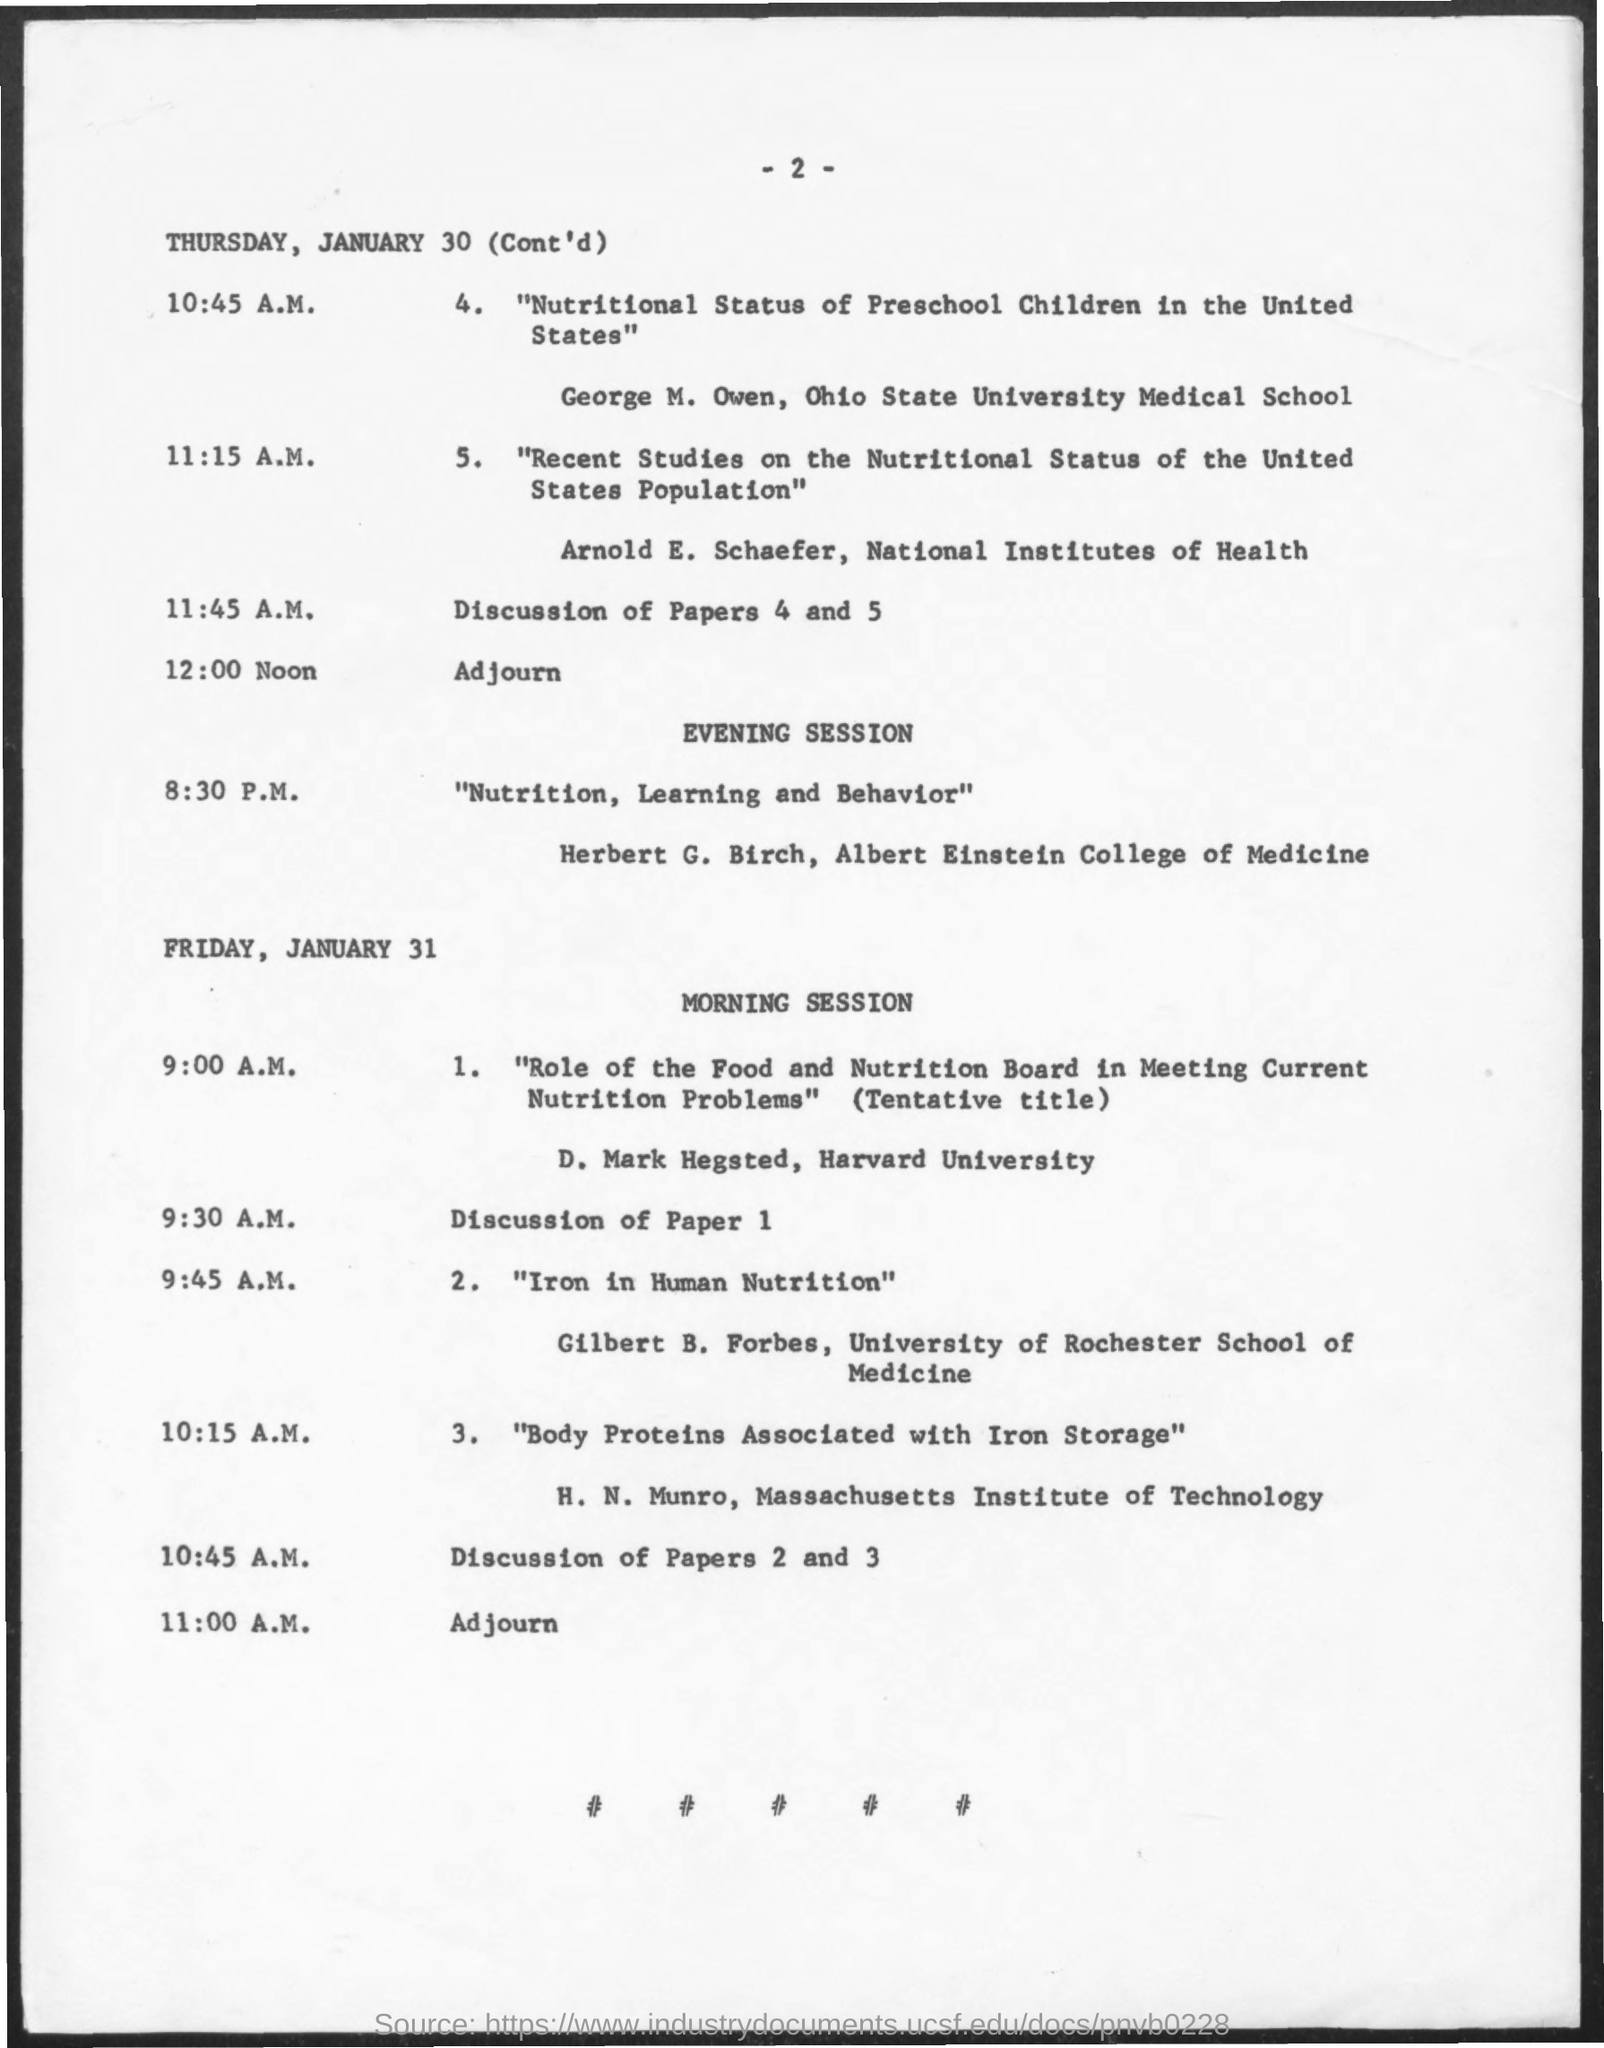Who conducted the paper on the topic " Nutritional Status of Preschool Children in the United states" on thursday?
Your answer should be compact. George M. Owen. When is the adjourn time on thursday?
Provide a short and direct response. 12:00 Noon. Who conducted the paper on the topic "Recent Studies on the Nutritional Status of the United States population" on thursday ?
Your answer should be compact. Arnold E. Schaefer. Who conducted the Paper on the topic "Role of the Food and Nutrition Board in Meeting Current Nutrition Problems" on Friday?
Keep it short and to the point. D. Mark Hegsted. Who conducted the paper on the topic " Iron in Human Nutrition " on Friday ?
Your answer should be compact. Gilbert B. Forbes. On which university,did " D. Mark Hegsted " is working ?
Your answer should be very brief. Harvard University. When will the evening session on 'January 30 Thursday' will begin after Adjourn ?
Offer a very short reply. 8:30 P.M. 